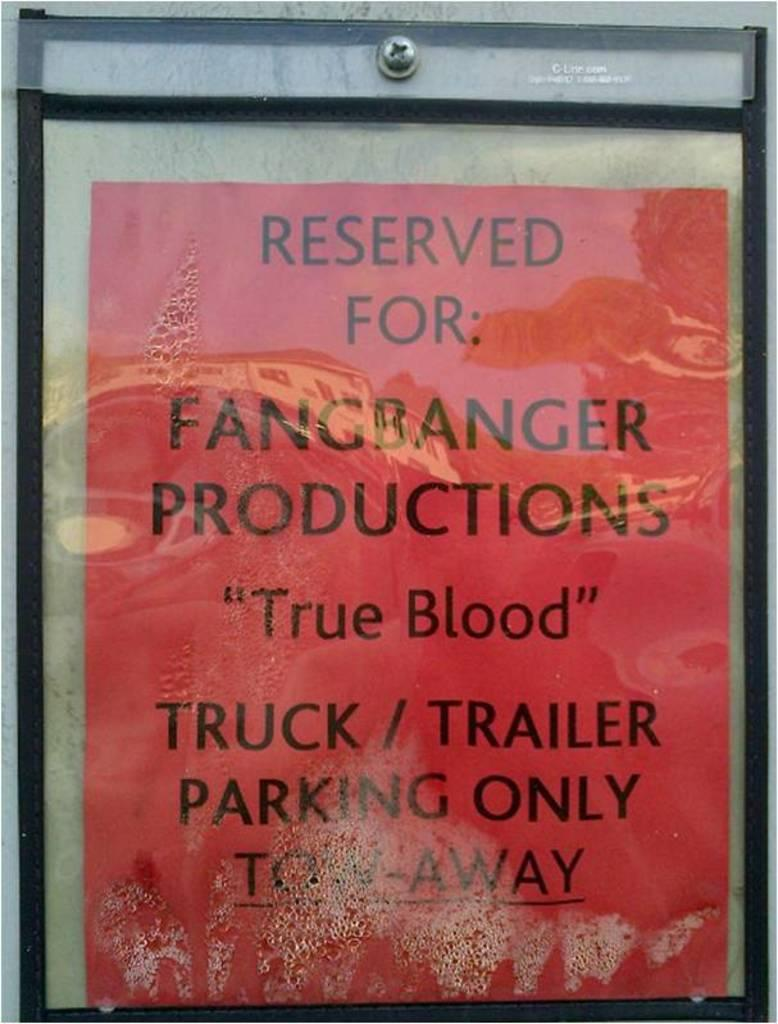<image>
Provide a brief description of the given image. A red paking sign says truck and trailers only. 